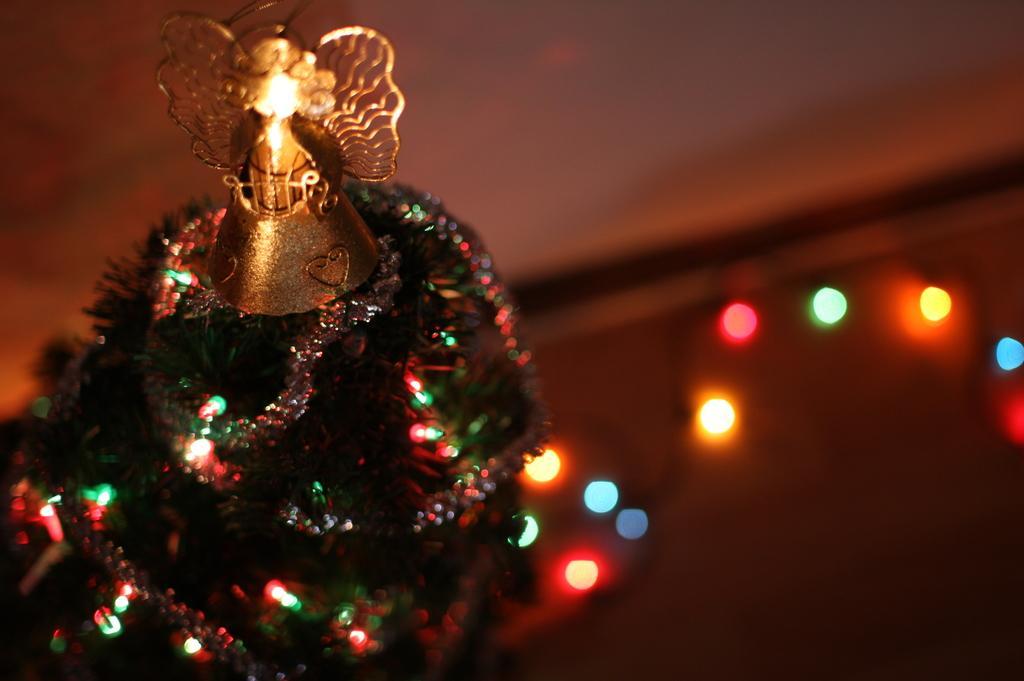Could you give a brief overview of what you see in this image? In the picture I can see a Christmas tree which is decorated with some objects. In the background I can see lights. The background of the image is blurred. 